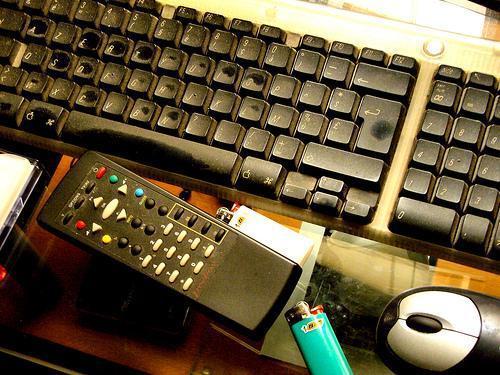How many lighters are there total?
Give a very brief answer. 2. How many black buttons does the remote have?
Give a very brief answer. 13. 